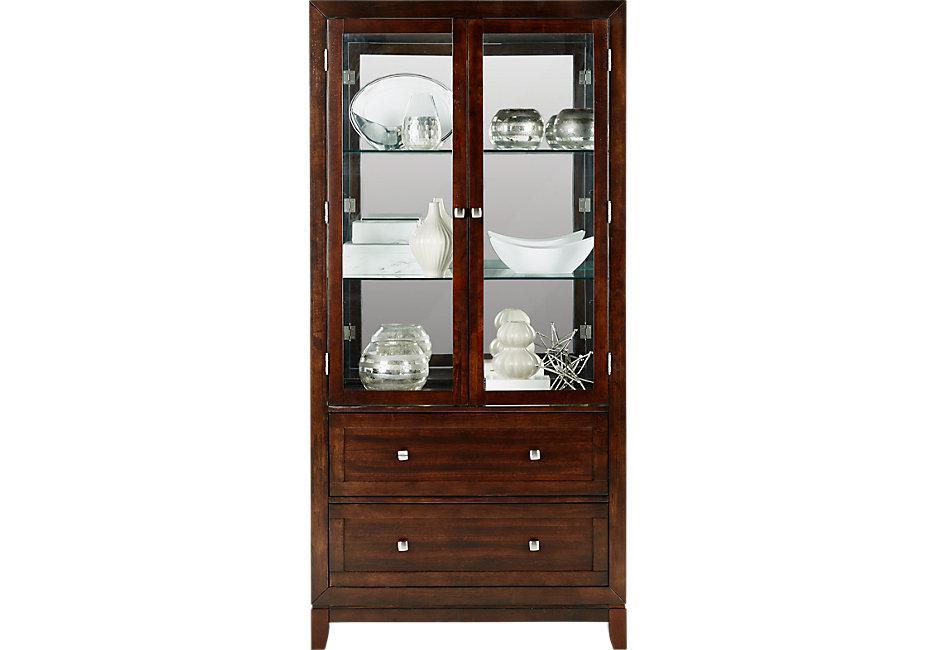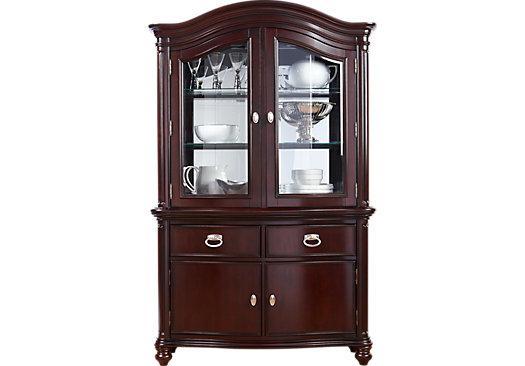The first image is the image on the left, the second image is the image on the right. Analyze the images presented: Is the assertion "One of the cabinets has an arched, curved top, and both cabinets have some type of feet." valid? Answer yes or no. Yes. The first image is the image on the left, the second image is the image on the right. Given the left and right images, does the statement "A wooden hutch in one image has a middle open section with three glass doors above, and a section with drawers and solid panel doors below." hold true? Answer yes or no. No. 